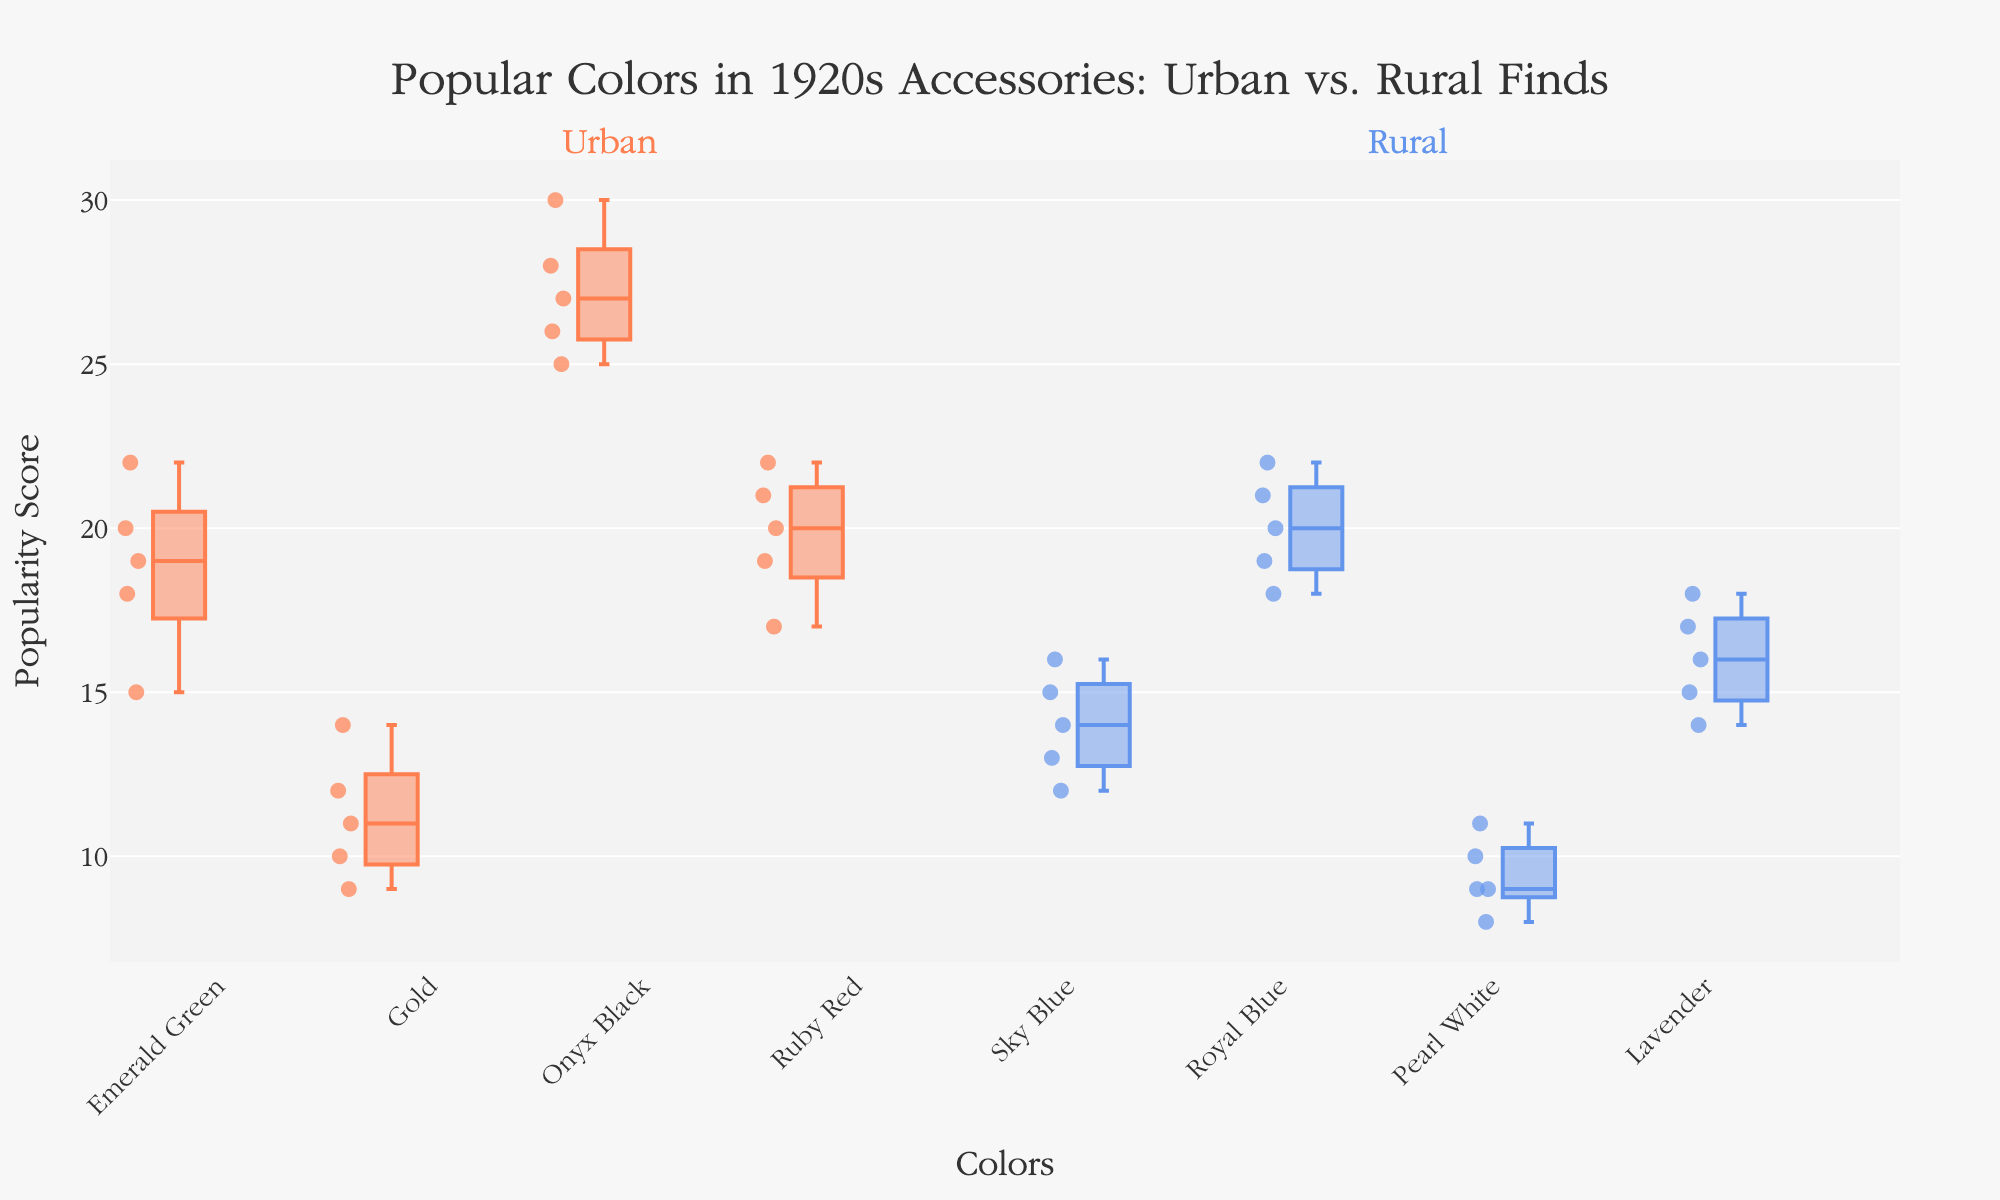Which color in Urban areas has the highest median value? Looking at the Urban box plots, the median is indicated by the line inside each box. Onyx Black has the highest median value among Urban colors.
Answer: Onyx Black In Rural areas, what is the interquartile range (IQR) for Sky Blue? The interquartile range (IQR) is the difference between the third quartile (Q3) and the first quartile (Q1). For Sky Blue in Rural areas, Q3 is at 15 and Q1 is at 13, so IQR = 15 - 13.
Answer: 2 Which Rural color has the most consistent values (smallest IQR)? Consistency can be interpreted as having the smallest IQR. By comparing the IQRs of Rural colors (Sky Blue, Royal Blue, Pearl White, Lavender), Pearl White has the smallest IQR.
Answer: Pearl White Are there any outliers for Ruby Red in Urban areas? Outliers are usually plotted as individual points outside the whiskers of the box plot. For Ruby Red in Urban areas, there are no points outside the whiskers, indicating no outliers.
Answer: No Which group has the higher median value for Emerald Green? Comparing the medians for Emerald Green in Urban, there is no corresponding box plot for Emerald Green in Rural areas, so Urban has the higher median by default.
Answer: Urban Does Gold in Urban areas show higher variability compared to Lavender in Rural areas? Higher variability can be identified by a larger IQR or presence of outliers. The IQR for Gold in Urban areas is 5 (14 - 9), while for Lavender in Rural areas it is 3 (18 - 15). Therefore, Gold in Urban has higher variability.
Answer: Yes What is the range of values for Royal Blue in Rural areas? The range is the difference between the maximum and minimum values. In Royal Blue for Rural areas, the minimum value is 18 and the maximum value is 22, so the range is 22 - 18.
Answer: 4 Which Urban color has the lowest median value? By examining the medians of Urban colors, Gold has the lowest median value.
Answer: Gold How does the median value of Ruby Red in Urban areas compare to the median value of Lavender in Rural areas? Comparing the median lines within the boxes, the median for Ruby Red in Urban is 20, while the median for Lavender in Rural is 16.
Answer: Ruby Red has a higher median 